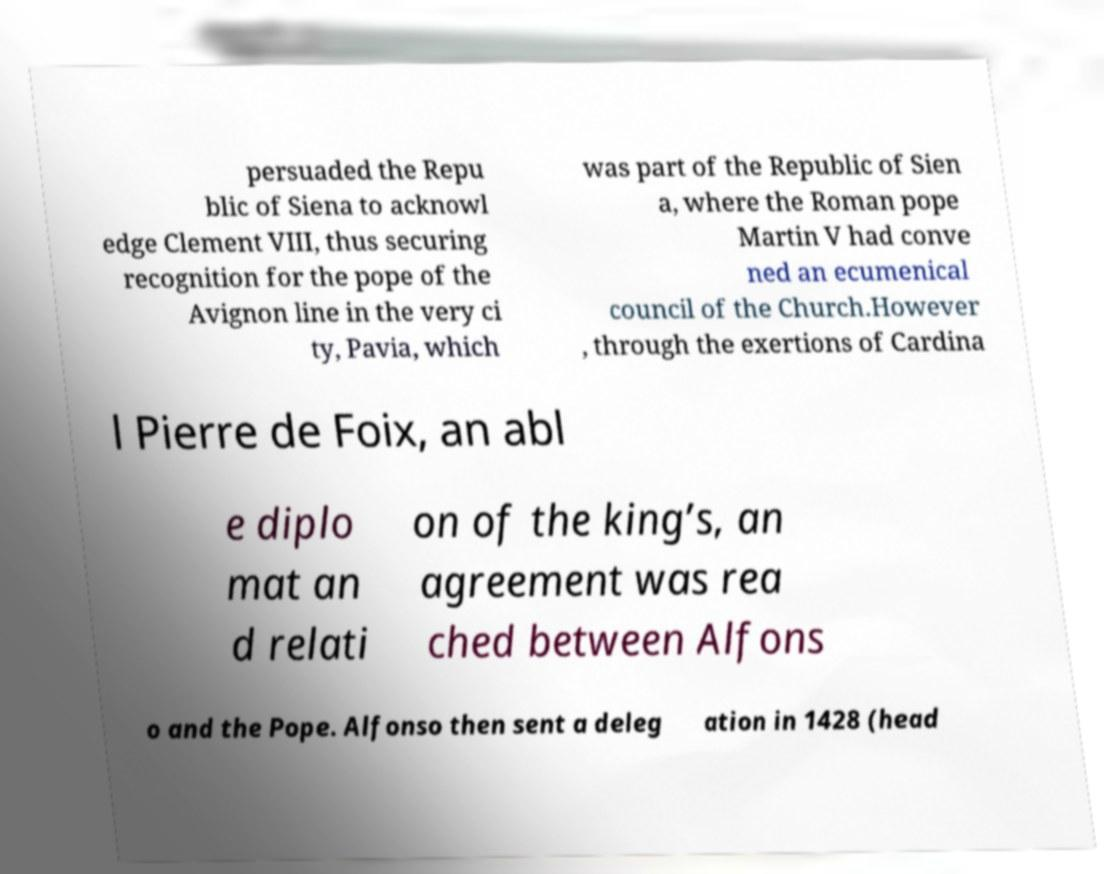What messages or text are displayed in this image? I need them in a readable, typed format. persuaded the Repu blic of Siena to acknowl edge Clement VIII, thus securing recognition for the pope of the Avignon line in the very ci ty, Pavia, which was part of the Republic of Sien a, where the Roman pope Martin V had conve ned an ecumenical council of the Church.However , through the exertions of Cardina l Pierre de Foix, an abl e diplo mat an d relati on of the king’s, an agreement was rea ched between Alfons o and the Pope. Alfonso then sent a deleg ation in 1428 (head 